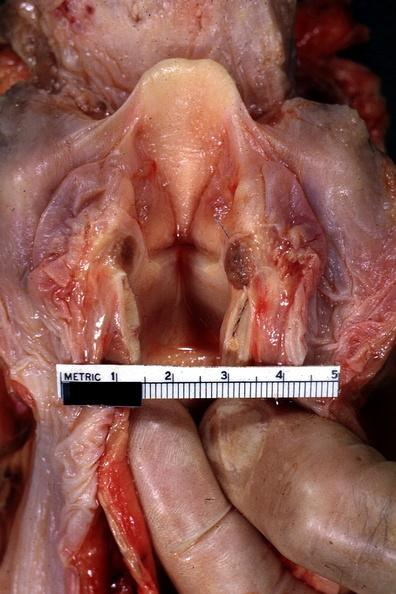what does this image show?
Answer the question using a single word or phrase. Opened larynx shows quite well 